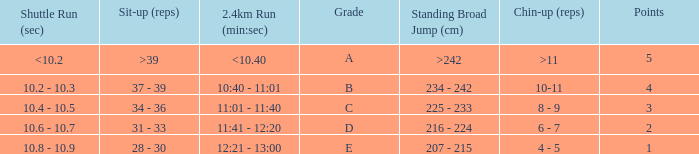Tell me the 2.4km run for points less than 2 12:21 - 13:00. 